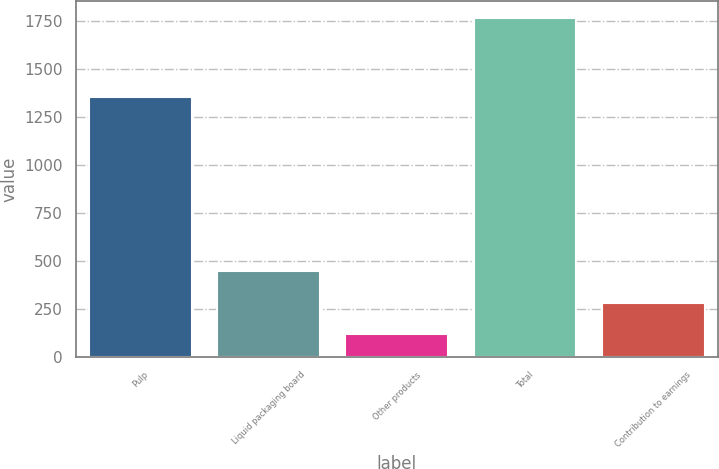Convert chart. <chart><loc_0><loc_0><loc_500><loc_500><bar_chart><fcel>Pulp<fcel>Liquid packaging board<fcel>Other products<fcel>Total<fcel>Contribution to earnings<nl><fcel>1357<fcel>447.4<fcel>118<fcel>1765<fcel>282.7<nl></chart> 